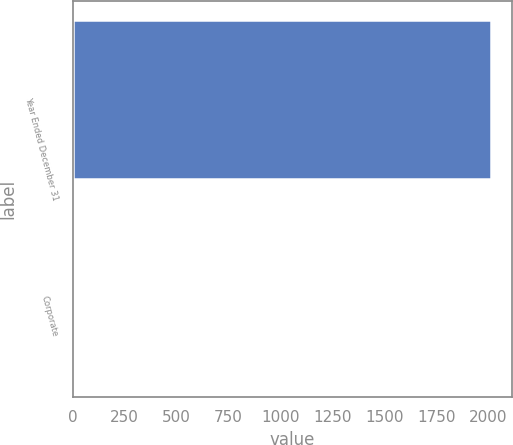Convert chart. <chart><loc_0><loc_0><loc_500><loc_500><bar_chart><fcel>Year Ended December 31<fcel>Corporate<nl><fcel>2014<fcel>6<nl></chart> 